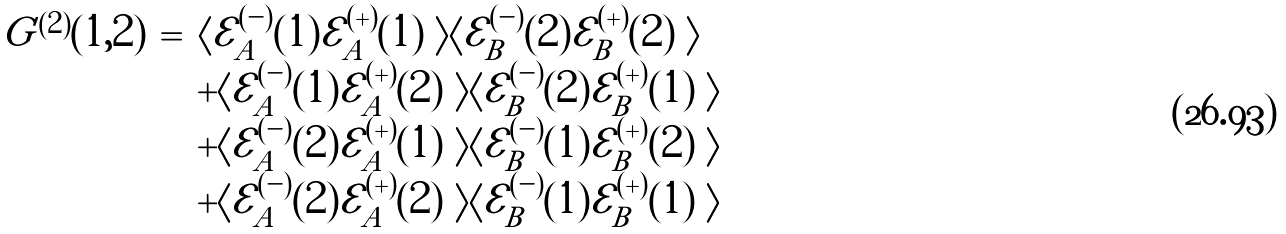<formula> <loc_0><loc_0><loc_500><loc_500>\begin{array} { c c l } G ^ { ( 2 ) } ( 1 , 2 ) & = & \langle \mathcal { E } ^ { ( - ) } _ { A } ( 1 ) \mathcal { E } ^ { ( + ) } _ { A } ( 1 ) \ \rangle \langle \mathcal { E } ^ { ( - ) } _ { B } ( 2 ) \mathcal { E } ^ { ( + ) } _ { B } ( 2 ) \ \rangle \\ & & + \langle \mathcal { E } ^ { ( - ) } _ { A } ( 1 ) \mathcal { E } ^ { ( + ) } _ { A } ( 2 ) \ \rangle \langle \mathcal { E } ^ { ( - ) } _ { B } ( 2 ) \mathcal { E } ^ { ( + ) } _ { B } ( 1 ) \ \rangle \\ & & + \langle \mathcal { E } ^ { ( - ) } _ { A } ( 2 ) \mathcal { E } ^ { ( + ) } _ { A } ( 1 ) \ \rangle \langle \mathcal { E } ^ { ( - ) } _ { B } ( 1 ) \mathcal { E } ^ { ( + ) } _ { B } ( 2 ) \ \rangle \\ & & + \langle \mathcal { E } ^ { ( - ) } _ { A } ( 2 ) \mathcal { E } ^ { ( + ) } _ { A } ( 2 ) \ \rangle \langle \mathcal { E } ^ { ( - ) } _ { B } ( 1 ) \mathcal { E } ^ { ( + ) } _ { B } ( 1 ) \ \rangle \end{array}</formula> 